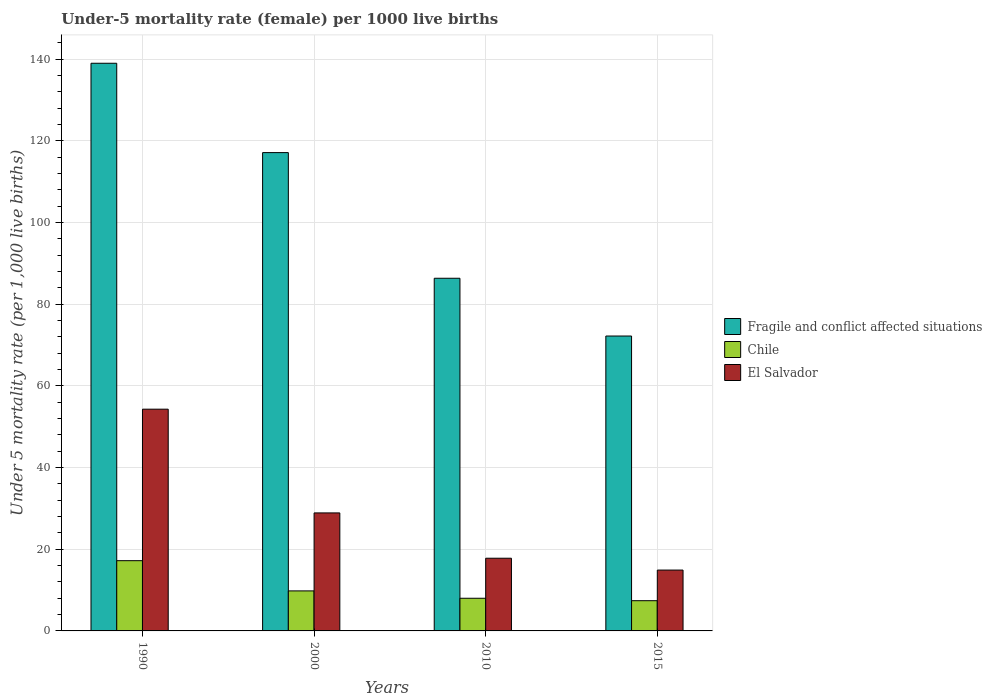Are the number of bars on each tick of the X-axis equal?
Your answer should be compact. Yes. What is the under-five mortality rate in Chile in 2015?
Your response must be concise. 7.4. Across all years, what is the maximum under-five mortality rate in Fragile and conflict affected situations?
Ensure brevity in your answer.  139.01. Across all years, what is the minimum under-five mortality rate in El Salvador?
Your answer should be compact. 14.9. In which year was the under-five mortality rate in Fragile and conflict affected situations minimum?
Your answer should be compact. 2015. What is the total under-five mortality rate in Chile in the graph?
Ensure brevity in your answer.  42.4. What is the difference between the under-five mortality rate in Chile in 1990 and that in 2010?
Provide a succinct answer. 9.2. What is the difference between the under-five mortality rate in El Salvador in 2010 and the under-five mortality rate in Chile in 2015?
Your answer should be compact. 10.4. What is the average under-five mortality rate in Fragile and conflict affected situations per year?
Your response must be concise. 103.68. In the year 1990, what is the difference between the under-five mortality rate in El Salvador and under-five mortality rate in Chile?
Ensure brevity in your answer.  37.1. In how many years, is the under-five mortality rate in El Salvador greater than 80?
Give a very brief answer. 0. What is the ratio of the under-five mortality rate in Fragile and conflict affected situations in 2010 to that in 2015?
Your answer should be very brief. 1.2. Is the under-five mortality rate in El Salvador in 2000 less than that in 2015?
Provide a short and direct response. No. What is the difference between the highest and the second highest under-five mortality rate in Chile?
Your answer should be compact. 7.4. What is the difference between the highest and the lowest under-five mortality rate in Fragile and conflict affected situations?
Ensure brevity in your answer.  66.8. Is the sum of the under-five mortality rate in Fragile and conflict affected situations in 1990 and 2000 greater than the maximum under-five mortality rate in Chile across all years?
Provide a short and direct response. Yes. What does the 1st bar from the left in 2000 represents?
Give a very brief answer. Fragile and conflict affected situations. What does the 3rd bar from the right in 2015 represents?
Your answer should be very brief. Fragile and conflict affected situations. Is it the case that in every year, the sum of the under-five mortality rate in Chile and under-five mortality rate in Fragile and conflict affected situations is greater than the under-five mortality rate in El Salvador?
Your answer should be very brief. Yes. How many bars are there?
Your answer should be very brief. 12. Are all the bars in the graph horizontal?
Ensure brevity in your answer.  No. How many years are there in the graph?
Keep it short and to the point. 4. What is the difference between two consecutive major ticks on the Y-axis?
Provide a short and direct response. 20. Does the graph contain any zero values?
Make the answer very short. No. Does the graph contain grids?
Give a very brief answer. Yes. Where does the legend appear in the graph?
Keep it short and to the point. Center right. How many legend labels are there?
Your answer should be very brief. 3. How are the legend labels stacked?
Your response must be concise. Vertical. What is the title of the graph?
Your answer should be very brief. Under-5 mortality rate (female) per 1000 live births. Does "Vanuatu" appear as one of the legend labels in the graph?
Your answer should be compact. No. What is the label or title of the X-axis?
Keep it short and to the point. Years. What is the label or title of the Y-axis?
Keep it short and to the point. Under 5 mortality rate (per 1,0 live births). What is the Under 5 mortality rate (per 1,000 live births) in Fragile and conflict affected situations in 1990?
Keep it short and to the point. 139.01. What is the Under 5 mortality rate (per 1,000 live births) of El Salvador in 1990?
Your answer should be compact. 54.3. What is the Under 5 mortality rate (per 1,000 live births) of Fragile and conflict affected situations in 2000?
Ensure brevity in your answer.  117.13. What is the Under 5 mortality rate (per 1,000 live births) in El Salvador in 2000?
Make the answer very short. 28.9. What is the Under 5 mortality rate (per 1,000 live births) of Fragile and conflict affected situations in 2010?
Provide a short and direct response. 86.36. What is the Under 5 mortality rate (per 1,000 live births) in Chile in 2010?
Make the answer very short. 8. What is the Under 5 mortality rate (per 1,000 live births) of Fragile and conflict affected situations in 2015?
Provide a short and direct response. 72.22. What is the Under 5 mortality rate (per 1,000 live births) of Chile in 2015?
Provide a succinct answer. 7.4. Across all years, what is the maximum Under 5 mortality rate (per 1,000 live births) of Fragile and conflict affected situations?
Ensure brevity in your answer.  139.01. Across all years, what is the maximum Under 5 mortality rate (per 1,000 live births) of Chile?
Your response must be concise. 17.2. Across all years, what is the maximum Under 5 mortality rate (per 1,000 live births) in El Salvador?
Keep it short and to the point. 54.3. Across all years, what is the minimum Under 5 mortality rate (per 1,000 live births) of Fragile and conflict affected situations?
Your answer should be very brief. 72.22. Across all years, what is the minimum Under 5 mortality rate (per 1,000 live births) in Chile?
Your response must be concise. 7.4. Across all years, what is the minimum Under 5 mortality rate (per 1,000 live births) in El Salvador?
Your response must be concise. 14.9. What is the total Under 5 mortality rate (per 1,000 live births) in Fragile and conflict affected situations in the graph?
Ensure brevity in your answer.  414.72. What is the total Under 5 mortality rate (per 1,000 live births) in Chile in the graph?
Your answer should be very brief. 42.4. What is the total Under 5 mortality rate (per 1,000 live births) in El Salvador in the graph?
Offer a terse response. 115.9. What is the difference between the Under 5 mortality rate (per 1,000 live births) of Fragile and conflict affected situations in 1990 and that in 2000?
Provide a succinct answer. 21.88. What is the difference between the Under 5 mortality rate (per 1,000 live births) of Chile in 1990 and that in 2000?
Provide a succinct answer. 7.4. What is the difference between the Under 5 mortality rate (per 1,000 live births) in El Salvador in 1990 and that in 2000?
Ensure brevity in your answer.  25.4. What is the difference between the Under 5 mortality rate (per 1,000 live births) of Fragile and conflict affected situations in 1990 and that in 2010?
Your answer should be compact. 52.65. What is the difference between the Under 5 mortality rate (per 1,000 live births) of Chile in 1990 and that in 2010?
Your response must be concise. 9.2. What is the difference between the Under 5 mortality rate (per 1,000 live births) in El Salvador in 1990 and that in 2010?
Your answer should be very brief. 36.5. What is the difference between the Under 5 mortality rate (per 1,000 live births) in Fragile and conflict affected situations in 1990 and that in 2015?
Provide a succinct answer. 66.8. What is the difference between the Under 5 mortality rate (per 1,000 live births) of Chile in 1990 and that in 2015?
Give a very brief answer. 9.8. What is the difference between the Under 5 mortality rate (per 1,000 live births) of El Salvador in 1990 and that in 2015?
Keep it short and to the point. 39.4. What is the difference between the Under 5 mortality rate (per 1,000 live births) of Fragile and conflict affected situations in 2000 and that in 2010?
Your answer should be very brief. 30.77. What is the difference between the Under 5 mortality rate (per 1,000 live births) of Fragile and conflict affected situations in 2000 and that in 2015?
Give a very brief answer. 44.92. What is the difference between the Under 5 mortality rate (per 1,000 live births) in El Salvador in 2000 and that in 2015?
Ensure brevity in your answer.  14. What is the difference between the Under 5 mortality rate (per 1,000 live births) of Fragile and conflict affected situations in 2010 and that in 2015?
Offer a terse response. 14.14. What is the difference between the Under 5 mortality rate (per 1,000 live births) in El Salvador in 2010 and that in 2015?
Your answer should be compact. 2.9. What is the difference between the Under 5 mortality rate (per 1,000 live births) in Fragile and conflict affected situations in 1990 and the Under 5 mortality rate (per 1,000 live births) in Chile in 2000?
Your answer should be compact. 129.21. What is the difference between the Under 5 mortality rate (per 1,000 live births) in Fragile and conflict affected situations in 1990 and the Under 5 mortality rate (per 1,000 live births) in El Salvador in 2000?
Offer a terse response. 110.11. What is the difference between the Under 5 mortality rate (per 1,000 live births) in Chile in 1990 and the Under 5 mortality rate (per 1,000 live births) in El Salvador in 2000?
Make the answer very short. -11.7. What is the difference between the Under 5 mortality rate (per 1,000 live births) in Fragile and conflict affected situations in 1990 and the Under 5 mortality rate (per 1,000 live births) in Chile in 2010?
Keep it short and to the point. 131.01. What is the difference between the Under 5 mortality rate (per 1,000 live births) of Fragile and conflict affected situations in 1990 and the Under 5 mortality rate (per 1,000 live births) of El Salvador in 2010?
Your answer should be very brief. 121.21. What is the difference between the Under 5 mortality rate (per 1,000 live births) in Fragile and conflict affected situations in 1990 and the Under 5 mortality rate (per 1,000 live births) in Chile in 2015?
Your answer should be compact. 131.61. What is the difference between the Under 5 mortality rate (per 1,000 live births) in Fragile and conflict affected situations in 1990 and the Under 5 mortality rate (per 1,000 live births) in El Salvador in 2015?
Your response must be concise. 124.11. What is the difference between the Under 5 mortality rate (per 1,000 live births) of Chile in 1990 and the Under 5 mortality rate (per 1,000 live births) of El Salvador in 2015?
Keep it short and to the point. 2.3. What is the difference between the Under 5 mortality rate (per 1,000 live births) in Fragile and conflict affected situations in 2000 and the Under 5 mortality rate (per 1,000 live births) in Chile in 2010?
Keep it short and to the point. 109.13. What is the difference between the Under 5 mortality rate (per 1,000 live births) of Fragile and conflict affected situations in 2000 and the Under 5 mortality rate (per 1,000 live births) of El Salvador in 2010?
Offer a terse response. 99.33. What is the difference between the Under 5 mortality rate (per 1,000 live births) in Fragile and conflict affected situations in 2000 and the Under 5 mortality rate (per 1,000 live births) in Chile in 2015?
Keep it short and to the point. 109.73. What is the difference between the Under 5 mortality rate (per 1,000 live births) of Fragile and conflict affected situations in 2000 and the Under 5 mortality rate (per 1,000 live births) of El Salvador in 2015?
Your answer should be very brief. 102.23. What is the difference between the Under 5 mortality rate (per 1,000 live births) in Chile in 2000 and the Under 5 mortality rate (per 1,000 live births) in El Salvador in 2015?
Your answer should be compact. -5.1. What is the difference between the Under 5 mortality rate (per 1,000 live births) in Fragile and conflict affected situations in 2010 and the Under 5 mortality rate (per 1,000 live births) in Chile in 2015?
Offer a very short reply. 78.96. What is the difference between the Under 5 mortality rate (per 1,000 live births) of Fragile and conflict affected situations in 2010 and the Under 5 mortality rate (per 1,000 live births) of El Salvador in 2015?
Make the answer very short. 71.46. What is the average Under 5 mortality rate (per 1,000 live births) of Fragile and conflict affected situations per year?
Offer a very short reply. 103.68. What is the average Under 5 mortality rate (per 1,000 live births) of Chile per year?
Provide a succinct answer. 10.6. What is the average Under 5 mortality rate (per 1,000 live births) of El Salvador per year?
Give a very brief answer. 28.98. In the year 1990, what is the difference between the Under 5 mortality rate (per 1,000 live births) in Fragile and conflict affected situations and Under 5 mortality rate (per 1,000 live births) in Chile?
Make the answer very short. 121.81. In the year 1990, what is the difference between the Under 5 mortality rate (per 1,000 live births) in Fragile and conflict affected situations and Under 5 mortality rate (per 1,000 live births) in El Salvador?
Ensure brevity in your answer.  84.71. In the year 1990, what is the difference between the Under 5 mortality rate (per 1,000 live births) in Chile and Under 5 mortality rate (per 1,000 live births) in El Salvador?
Offer a terse response. -37.1. In the year 2000, what is the difference between the Under 5 mortality rate (per 1,000 live births) in Fragile and conflict affected situations and Under 5 mortality rate (per 1,000 live births) in Chile?
Provide a succinct answer. 107.33. In the year 2000, what is the difference between the Under 5 mortality rate (per 1,000 live births) of Fragile and conflict affected situations and Under 5 mortality rate (per 1,000 live births) of El Salvador?
Provide a short and direct response. 88.23. In the year 2000, what is the difference between the Under 5 mortality rate (per 1,000 live births) in Chile and Under 5 mortality rate (per 1,000 live births) in El Salvador?
Provide a succinct answer. -19.1. In the year 2010, what is the difference between the Under 5 mortality rate (per 1,000 live births) of Fragile and conflict affected situations and Under 5 mortality rate (per 1,000 live births) of Chile?
Provide a short and direct response. 78.36. In the year 2010, what is the difference between the Under 5 mortality rate (per 1,000 live births) in Fragile and conflict affected situations and Under 5 mortality rate (per 1,000 live births) in El Salvador?
Make the answer very short. 68.56. In the year 2010, what is the difference between the Under 5 mortality rate (per 1,000 live births) of Chile and Under 5 mortality rate (per 1,000 live births) of El Salvador?
Offer a very short reply. -9.8. In the year 2015, what is the difference between the Under 5 mortality rate (per 1,000 live births) of Fragile and conflict affected situations and Under 5 mortality rate (per 1,000 live births) of Chile?
Provide a succinct answer. 64.82. In the year 2015, what is the difference between the Under 5 mortality rate (per 1,000 live births) of Fragile and conflict affected situations and Under 5 mortality rate (per 1,000 live births) of El Salvador?
Offer a very short reply. 57.32. In the year 2015, what is the difference between the Under 5 mortality rate (per 1,000 live births) of Chile and Under 5 mortality rate (per 1,000 live births) of El Salvador?
Provide a short and direct response. -7.5. What is the ratio of the Under 5 mortality rate (per 1,000 live births) in Fragile and conflict affected situations in 1990 to that in 2000?
Your response must be concise. 1.19. What is the ratio of the Under 5 mortality rate (per 1,000 live births) in Chile in 1990 to that in 2000?
Ensure brevity in your answer.  1.76. What is the ratio of the Under 5 mortality rate (per 1,000 live births) in El Salvador in 1990 to that in 2000?
Make the answer very short. 1.88. What is the ratio of the Under 5 mortality rate (per 1,000 live births) of Fragile and conflict affected situations in 1990 to that in 2010?
Your response must be concise. 1.61. What is the ratio of the Under 5 mortality rate (per 1,000 live births) in Chile in 1990 to that in 2010?
Keep it short and to the point. 2.15. What is the ratio of the Under 5 mortality rate (per 1,000 live births) of El Salvador in 1990 to that in 2010?
Keep it short and to the point. 3.05. What is the ratio of the Under 5 mortality rate (per 1,000 live births) in Fragile and conflict affected situations in 1990 to that in 2015?
Offer a terse response. 1.93. What is the ratio of the Under 5 mortality rate (per 1,000 live births) in Chile in 1990 to that in 2015?
Offer a terse response. 2.32. What is the ratio of the Under 5 mortality rate (per 1,000 live births) of El Salvador in 1990 to that in 2015?
Provide a succinct answer. 3.64. What is the ratio of the Under 5 mortality rate (per 1,000 live births) of Fragile and conflict affected situations in 2000 to that in 2010?
Provide a succinct answer. 1.36. What is the ratio of the Under 5 mortality rate (per 1,000 live births) in Chile in 2000 to that in 2010?
Provide a succinct answer. 1.23. What is the ratio of the Under 5 mortality rate (per 1,000 live births) of El Salvador in 2000 to that in 2010?
Your answer should be compact. 1.62. What is the ratio of the Under 5 mortality rate (per 1,000 live births) in Fragile and conflict affected situations in 2000 to that in 2015?
Make the answer very short. 1.62. What is the ratio of the Under 5 mortality rate (per 1,000 live births) of Chile in 2000 to that in 2015?
Offer a very short reply. 1.32. What is the ratio of the Under 5 mortality rate (per 1,000 live births) of El Salvador in 2000 to that in 2015?
Keep it short and to the point. 1.94. What is the ratio of the Under 5 mortality rate (per 1,000 live births) in Fragile and conflict affected situations in 2010 to that in 2015?
Your response must be concise. 1.2. What is the ratio of the Under 5 mortality rate (per 1,000 live births) in Chile in 2010 to that in 2015?
Offer a very short reply. 1.08. What is the ratio of the Under 5 mortality rate (per 1,000 live births) of El Salvador in 2010 to that in 2015?
Ensure brevity in your answer.  1.19. What is the difference between the highest and the second highest Under 5 mortality rate (per 1,000 live births) of Fragile and conflict affected situations?
Make the answer very short. 21.88. What is the difference between the highest and the second highest Under 5 mortality rate (per 1,000 live births) in El Salvador?
Give a very brief answer. 25.4. What is the difference between the highest and the lowest Under 5 mortality rate (per 1,000 live births) of Fragile and conflict affected situations?
Offer a terse response. 66.8. What is the difference between the highest and the lowest Under 5 mortality rate (per 1,000 live births) in El Salvador?
Provide a short and direct response. 39.4. 